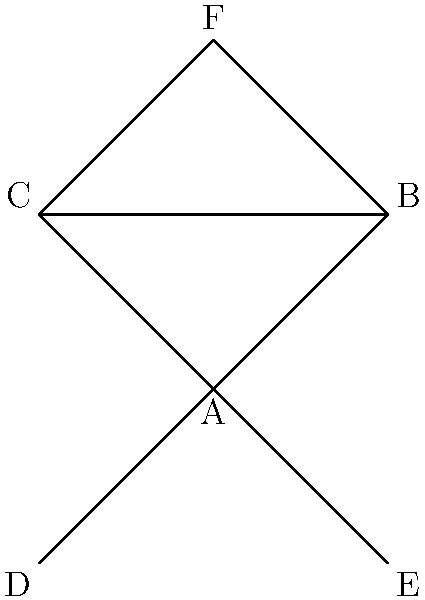At a literary festival, six authors (A, B, C, D, E, and F) have formed connections based on their collaborations and shared interests. The graph above represents these connections. Which author has the highest degree centrality, and what is their degree? To solve this problem, we need to understand the concept of degree centrality and then analyze the graph:

1. Degree centrality is the number of direct connections an author has to other authors in the network.

2. Let's count the connections for each author:
   - Author A: Connected to B, C, D, and E (4 connections)
   - Author B: Connected to A, C, and F (3 connections)
   - Author C: Connected to A, B, and F (3 connections)
   - Author D: Connected to A only (1 connection)
   - Author E: Connected to A only (1 connection)
   - Author F: Connected to B and C (2 connections)

3. The author with the highest number of connections is A, with 4 connections.

4. Therefore, Author A has the highest degree centrality, and their degree is 4.
Answer: Author A, degree 4 